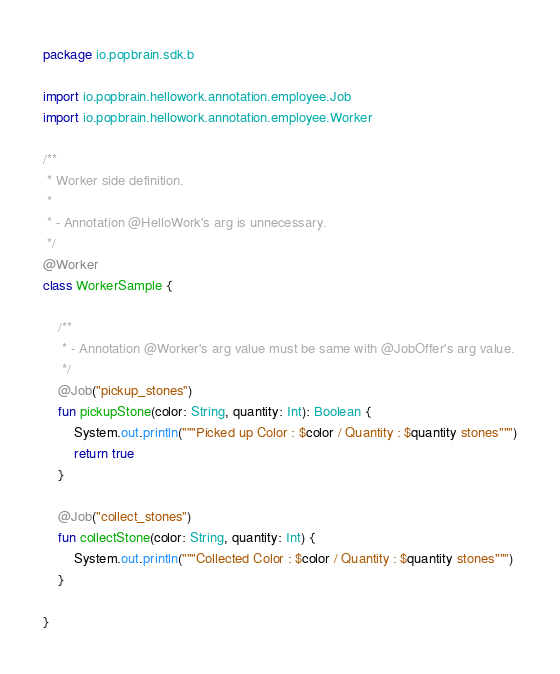Convert code to text. <code><loc_0><loc_0><loc_500><loc_500><_Kotlin_>package io.popbrain.sdk.b

import io.popbrain.hellowork.annotation.employee.Job
import io.popbrain.hellowork.annotation.employee.Worker

/**
 * Worker side definition.
 *
 * - Annotation @HelloWork's arg is unnecessary.
 */
@Worker
class WorkerSample {

    /**
     * - Annotation @Worker's arg value must be same with @JobOffer's arg value.
     */
    @Job("pickup_stones")
    fun pickupStone(color: String, quantity: Int): Boolean {
        System.out.println("""Picked up Color : $color / Quantity : $quantity stones""")
        return true
    }

    @Job("collect_stones")
    fun collectStone(color: String, quantity: Int) {
        System.out.println("""Collected Color : $color / Quantity : $quantity stones""")
    }

}</code> 